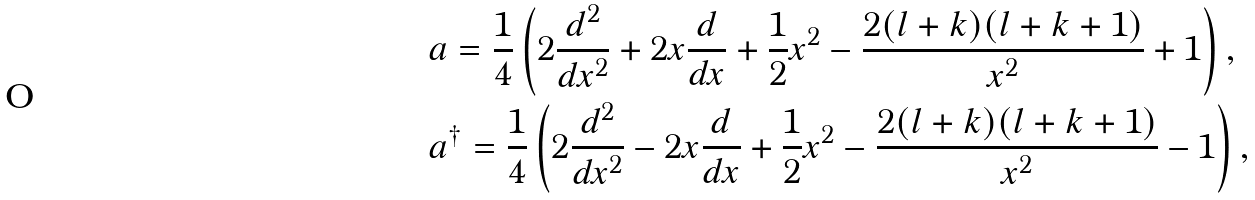Convert formula to latex. <formula><loc_0><loc_0><loc_500><loc_500>& a = \frac { 1 } { 4 } \left ( 2 \frac { d ^ { 2 } } { d x ^ { 2 } } + 2 x \frac { d } { d x } + \frac { 1 } { 2 } x ^ { 2 } - \frac { 2 ( l + k ) ( l + k + 1 ) } { x ^ { 2 } } + 1 \right ) , \\ & a ^ { \dagger } = \frac { 1 } { 4 } \left ( 2 \frac { d ^ { 2 } } { d x ^ { 2 } } - 2 x \frac { d } { d x } + \frac { 1 } { 2 } x ^ { 2 } - \frac { 2 ( l + k ) ( l + k + 1 ) } { x ^ { 2 } } - 1 \right ) ,</formula> 